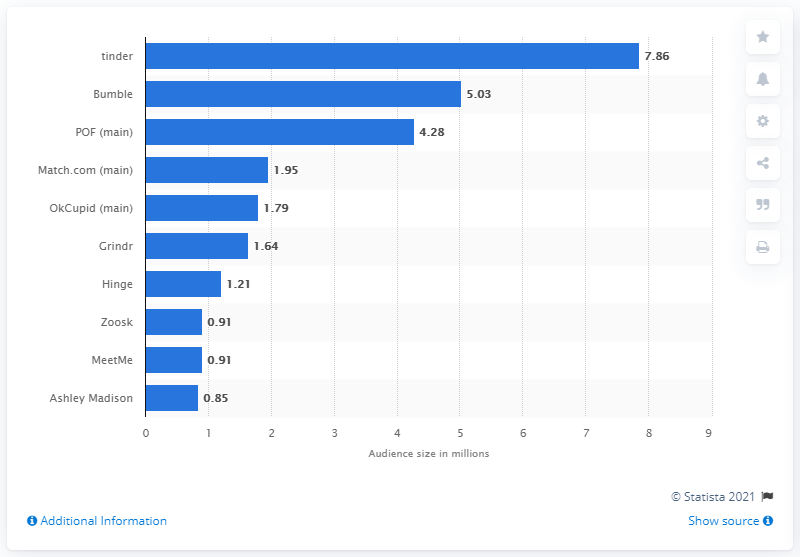Indicate a few pertinent items in this graphic. As of September 2019, Tinder had 7.86 million users. In September 2019, Bumble had approximately 5.03 million mobile users. 